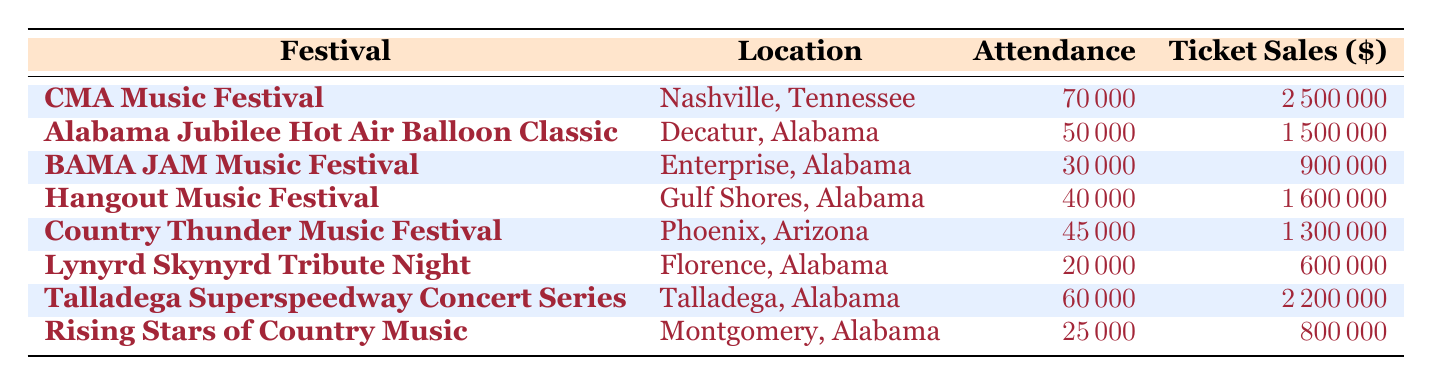What is the attendance for the Hangout Music Festival? The attendance for the Hangout Music Festival, which is listed in the table under Attendance, is 40,000.
Answer: 40,000 Which festival had the highest ticket sales, and what was the amount? Looking for the row with the maximum ticket sales value, the CMA Music Festival has the highest ticket sales of 2,500,000.
Answer: CMA Music Festival, 2,500,000 Is the attendance for the BAMA JAM Music Festival greater than 30,000? The attendance for the BAMA JAM Music Festival is 30,000, which is not greater than 30,000, hence the answer is no.
Answer: No What is the average attendance of all the Alabama festivals listed in the table? The total attendance for Alabama festivals: (50,000 + 30,000 + 40,000 + 20,000 + 60,000 + 25,000) = 225,000. There are 6 Alabama festivals, so the average attendance is 225,000 / 6 = 37,500.
Answer: 37,500 How many festivals in Alabama had attendance over 40,000? The festivals in Alabama that had attendance over 40,000 are: Alabama Jubilee Hot Air Balloon Classic (50,000), Hangout Music Festival (40,000), and Talladega Superspeedway Concert Series (60,000). Therefore, there are 3 festivals.
Answer: 3 What is the difference in ticket sales between the Talladega Superspeedway Concert Series and the Lynyrd Skynyrd Tribute Night? Ticket sales for Talladega Superspeedway Concert Series is 2,200,000 and for Lynyrd Skynyrd Tribute Night is 600,000. The difference is 2,200,000 - 600,000 = 1,600,000.
Answer: 1,600,000 Did the Rising Stars of Country Music generate more ticket sales than BAMA JAM Music Festival? The ticket sales for Rising Stars of Country Music is 800,000 and for BAMA JAM Music Festival is 900,000. Since 800,000 is less than 900,000, the answer is no.
Answer: No Which festival had the lowest attendance among those listed in Alabama? Looking through the attendance values of the Alabama festivals: 50,000 (Alabama Jubilee), 30,000 (BAMA JAM), 40,000 (Hangout), 20,000 (Lynyrd Skynyrd), 60,000 (Talladega), and 25,000 (Rising Stars). Lynyrd Skynyrd Tribute Night has the lowest attendance of 20,000.
Answer: Lynyrd Skynyrd Tribute Night, 20,000 